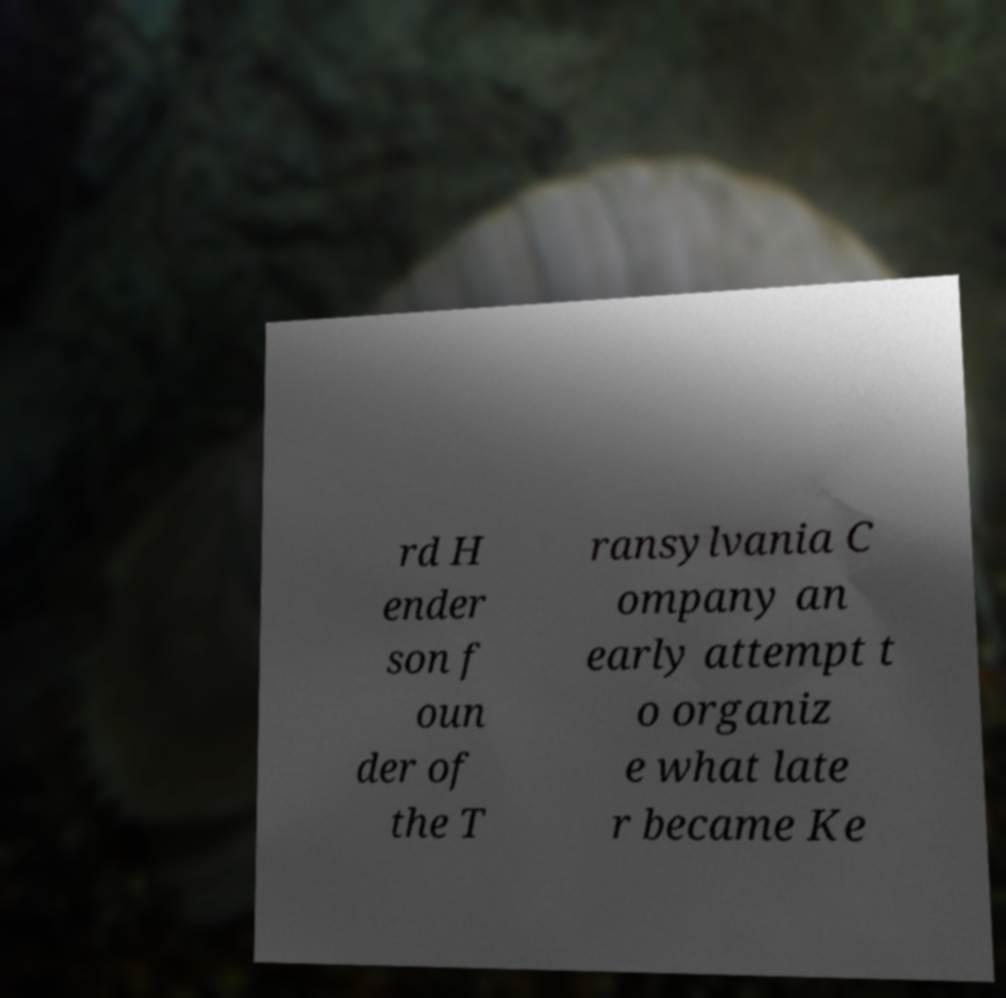There's text embedded in this image that I need extracted. Can you transcribe it verbatim? rd H ender son f oun der of the T ransylvania C ompany an early attempt t o organiz e what late r became Ke 